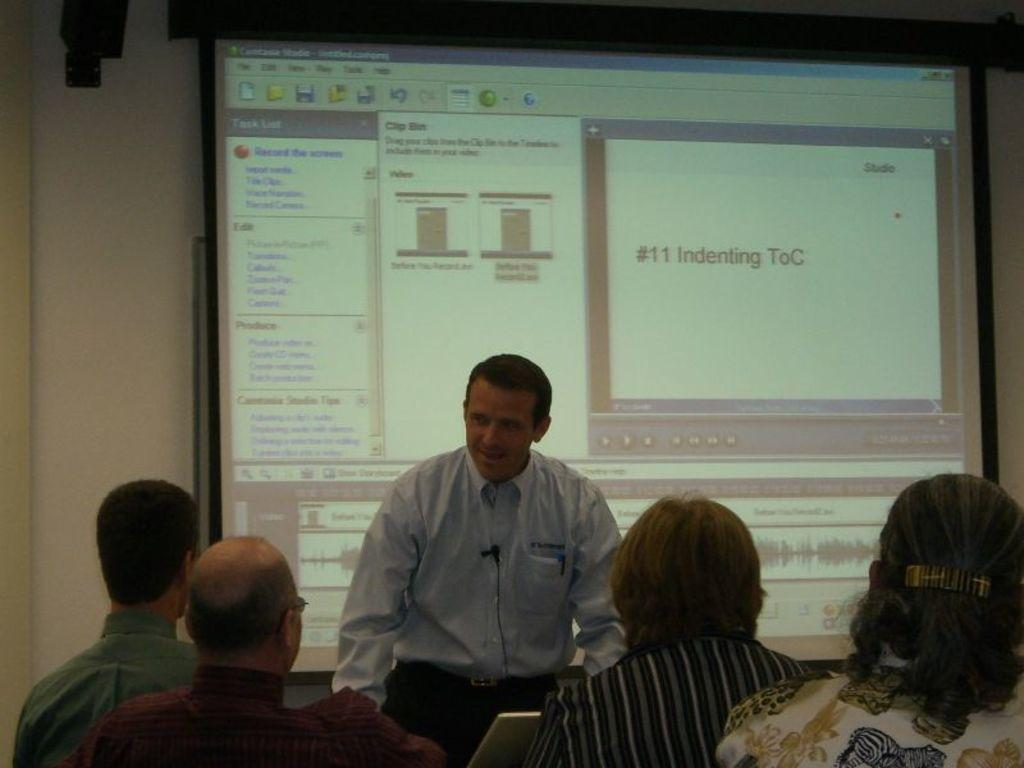What is the primary action of the man in the image? The man is standing in the image. What are the other people in the image doing? There are people sitting in the image. What can be seen in the background of the image? There is a screen in the background of the image. What is being shown on the screen? Something is displayed on the screen. What type of oatmeal is being served to the people sitting in the image? There is no oatmeal present in the image; the people are sitting but no food is mentioned or visible. 